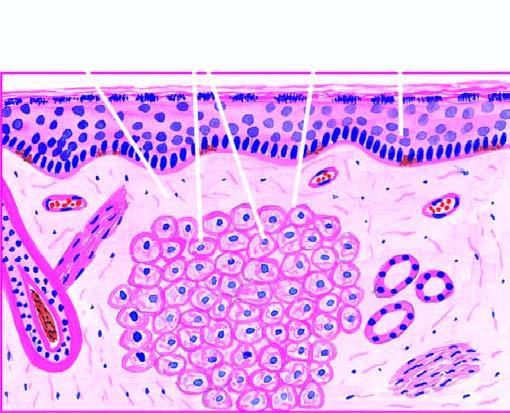what is there of proliferating foam macrophages in the dermis with a clear subepidermal zone?
Answer the question using a single word or phrase. Collection of proliferating foam macrophages 